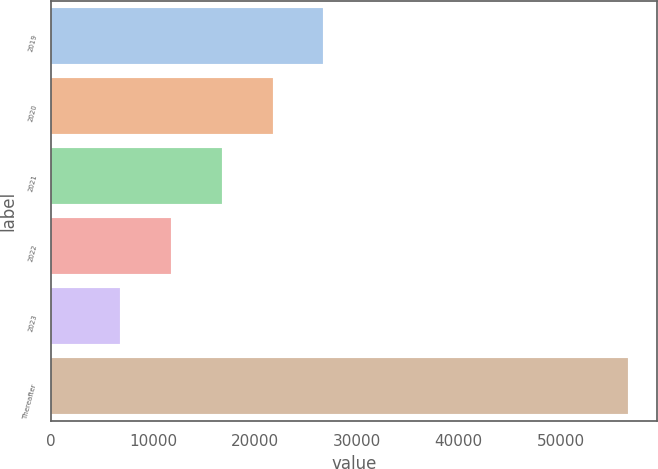Convert chart. <chart><loc_0><loc_0><loc_500><loc_500><bar_chart><fcel>2019<fcel>2020<fcel>2021<fcel>2022<fcel>2023<fcel>Thereafter<nl><fcel>26713.4<fcel>21728.8<fcel>16744.2<fcel>11759.6<fcel>6775<fcel>56621<nl></chart> 